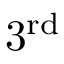Convert formula to latex. <formula><loc_0><loc_0><loc_500><loc_500>3 ^ { r d }</formula> 